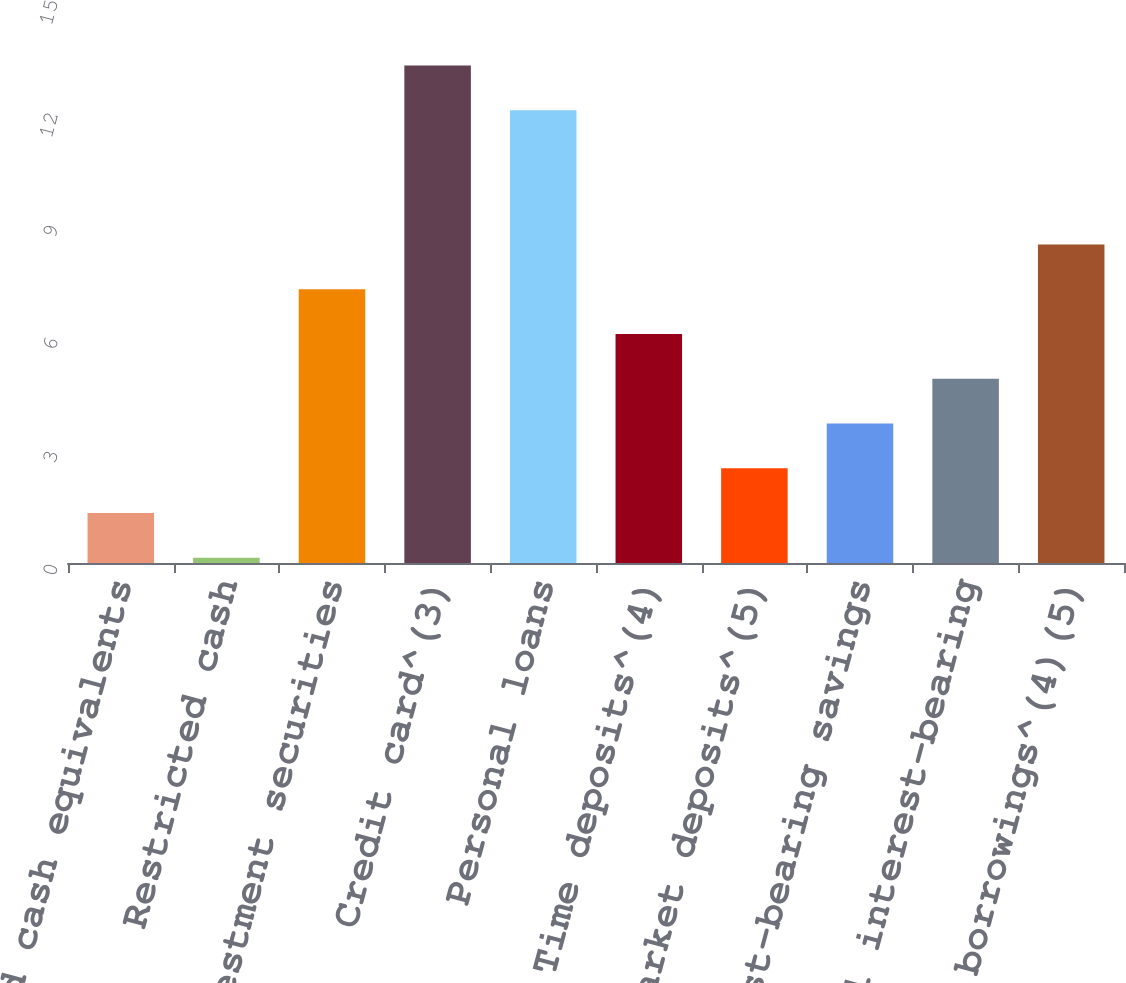Convert chart to OTSL. <chart><loc_0><loc_0><loc_500><loc_500><bar_chart><fcel>Cash and cash equivalents<fcel>Restricted cash<fcel>Investment securities<fcel>Credit card^(3)<fcel>Personal loans<fcel>Time deposits^(4)<fcel>Money market deposits^(5)<fcel>Other interest-bearing savings<fcel>Total interest-bearing<fcel>Securitized borrowings^(4)(5)<nl><fcel>1.33<fcel>0.14<fcel>7.28<fcel>13.23<fcel>12.04<fcel>6.09<fcel>2.52<fcel>3.71<fcel>4.9<fcel>8.47<nl></chart> 